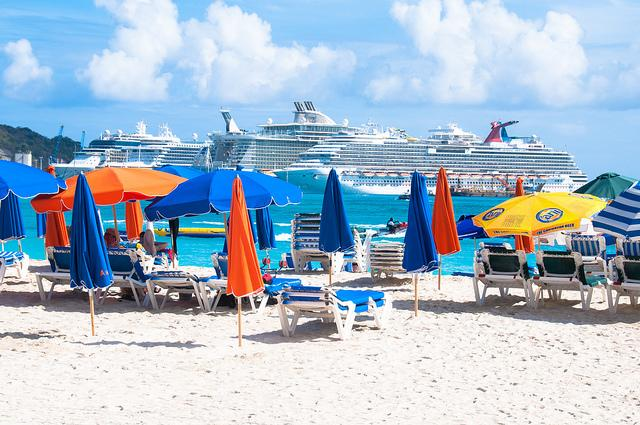What kind of ship is the one in the water?

Choices:
A) container
B) naval
C) passenger
D) tanker passenger 